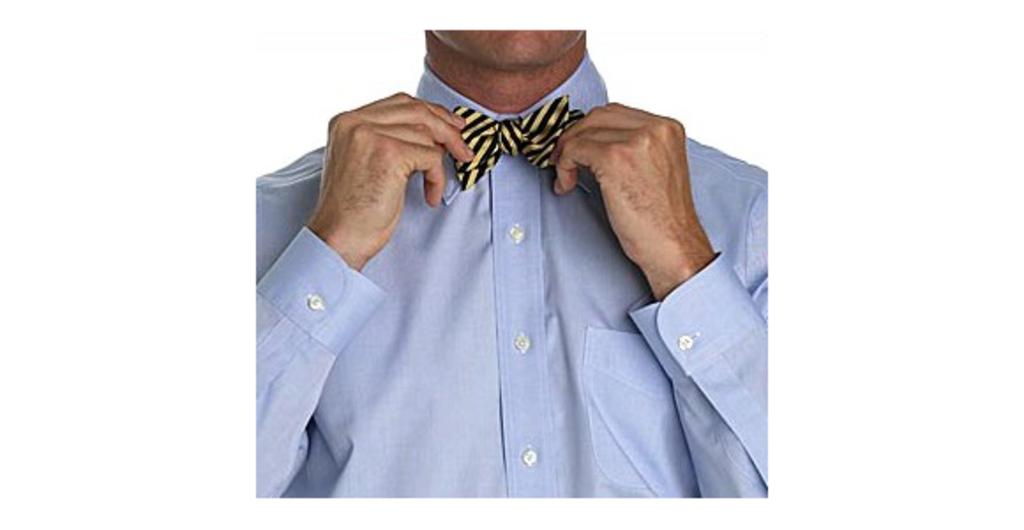What is the main subject of the image? There is a man in the image. What is the man doing in the image? The man is adjusting his bow tie. What type of clothing is the man wearing in the image? The man is wearing a shirt. What type of harmony is the man playing on his leg in the image? There is no instrument or leg visible in the image, and the man is adjusting his bow tie, not playing any harmony. 